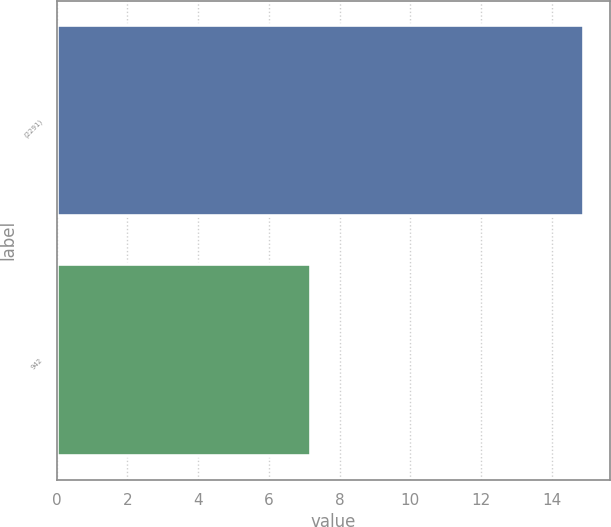<chart> <loc_0><loc_0><loc_500><loc_500><bar_chart><fcel>(2291)<fcel>942<nl><fcel>14.9<fcel>7.2<nl></chart> 